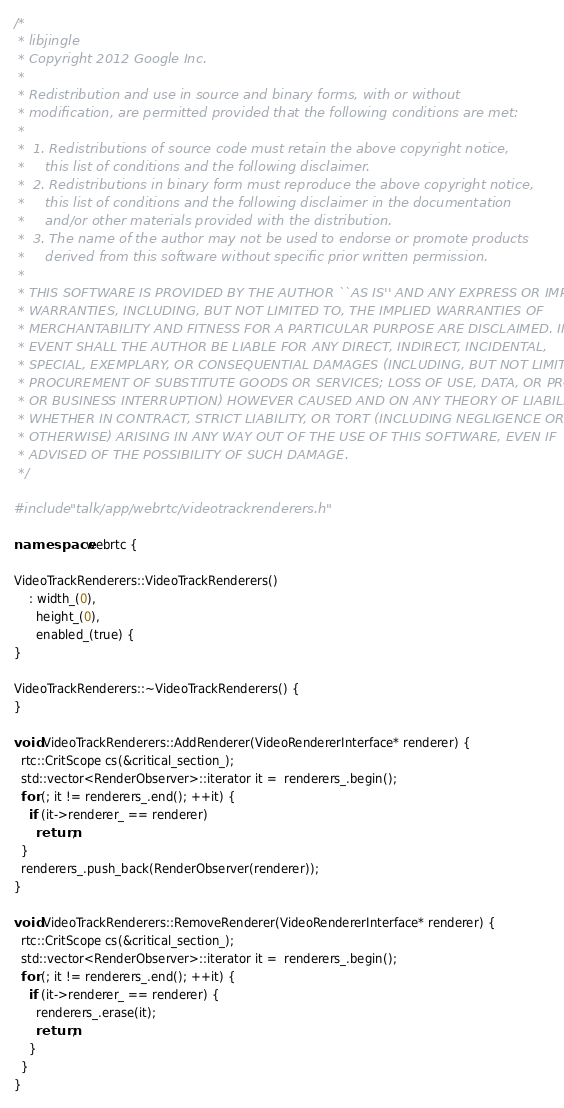Convert code to text. <code><loc_0><loc_0><loc_500><loc_500><_C++_>/*
 * libjingle
 * Copyright 2012 Google Inc.
 *
 * Redistribution and use in source and binary forms, with or without
 * modification, are permitted provided that the following conditions are met:
 *
 *  1. Redistributions of source code must retain the above copyright notice,
 *     this list of conditions and the following disclaimer.
 *  2. Redistributions in binary form must reproduce the above copyright notice,
 *     this list of conditions and the following disclaimer in the documentation
 *     and/or other materials provided with the distribution.
 *  3. The name of the author may not be used to endorse or promote products
 *     derived from this software without specific prior written permission.
 *
 * THIS SOFTWARE IS PROVIDED BY THE AUTHOR ``AS IS'' AND ANY EXPRESS OR IMPLIED
 * WARRANTIES, INCLUDING, BUT NOT LIMITED TO, THE IMPLIED WARRANTIES OF
 * MERCHANTABILITY AND FITNESS FOR A PARTICULAR PURPOSE ARE DISCLAIMED. IN NO
 * EVENT SHALL THE AUTHOR BE LIABLE FOR ANY DIRECT, INDIRECT, INCIDENTAL,
 * SPECIAL, EXEMPLARY, OR CONSEQUENTIAL DAMAGES (INCLUDING, BUT NOT LIMITED TO,
 * PROCUREMENT OF SUBSTITUTE GOODS OR SERVICES; LOSS OF USE, DATA, OR PROFITS;
 * OR BUSINESS INTERRUPTION) HOWEVER CAUSED AND ON ANY THEORY OF LIABILITY,
 * WHETHER IN CONTRACT, STRICT LIABILITY, OR TORT (INCLUDING NEGLIGENCE OR
 * OTHERWISE) ARISING IN ANY WAY OUT OF THE USE OF THIS SOFTWARE, EVEN IF
 * ADVISED OF THE POSSIBILITY OF SUCH DAMAGE.
 */

#include "talk/app/webrtc/videotrackrenderers.h"

namespace webrtc {

VideoTrackRenderers::VideoTrackRenderers()
    : width_(0),
      height_(0),
      enabled_(true) {
}

VideoTrackRenderers::~VideoTrackRenderers() {
}

void VideoTrackRenderers::AddRenderer(VideoRendererInterface* renderer) {
  rtc::CritScope cs(&critical_section_);
  std::vector<RenderObserver>::iterator it =  renderers_.begin();
  for (; it != renderers_.end(); ++it) {
    if (it->renderer_ == renderer)
      return;
  }
  renderers_.push_back(RenderObserver(renderer));
}

void VideoTrackRenderers::RemoveRenderer(VideoRendererInterface* renderer) {
  rtc::CritScope cs(&critical_section_);
  std::vector<RenderObserver>::iterator it =  renderers_.begin();
  for (; it != renderers_.end(); ++it) {
    if (it->renderer_ == renderer) {
      renderers_.erase(it);
      return;
    }
  }
}
</code> 